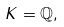<formula> <loc_0><loc_0><loc_500><loc_500>K = \mathbb { Q } ,</formula> 